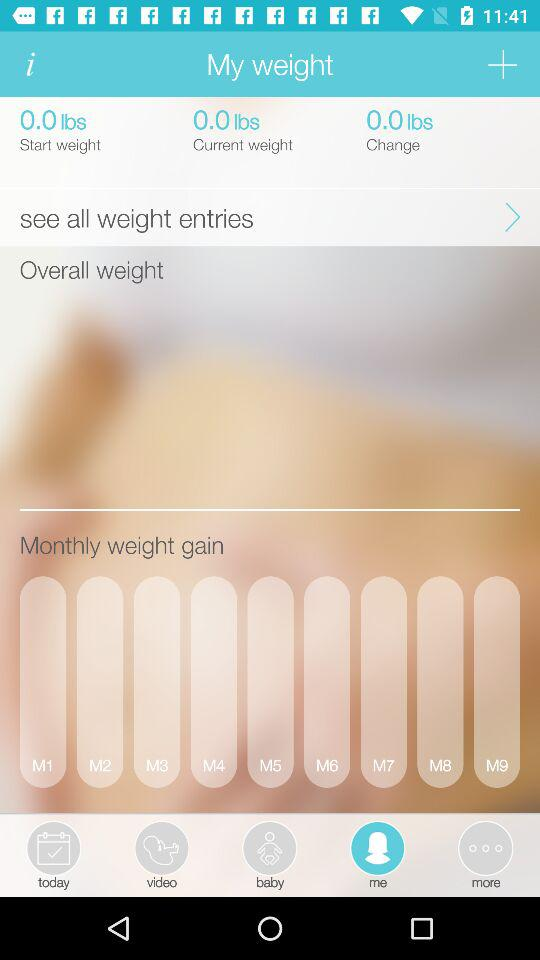What is the difference between the current weight and the start weight?
Answer the question using a single word or phrase. 0.0 lbs 